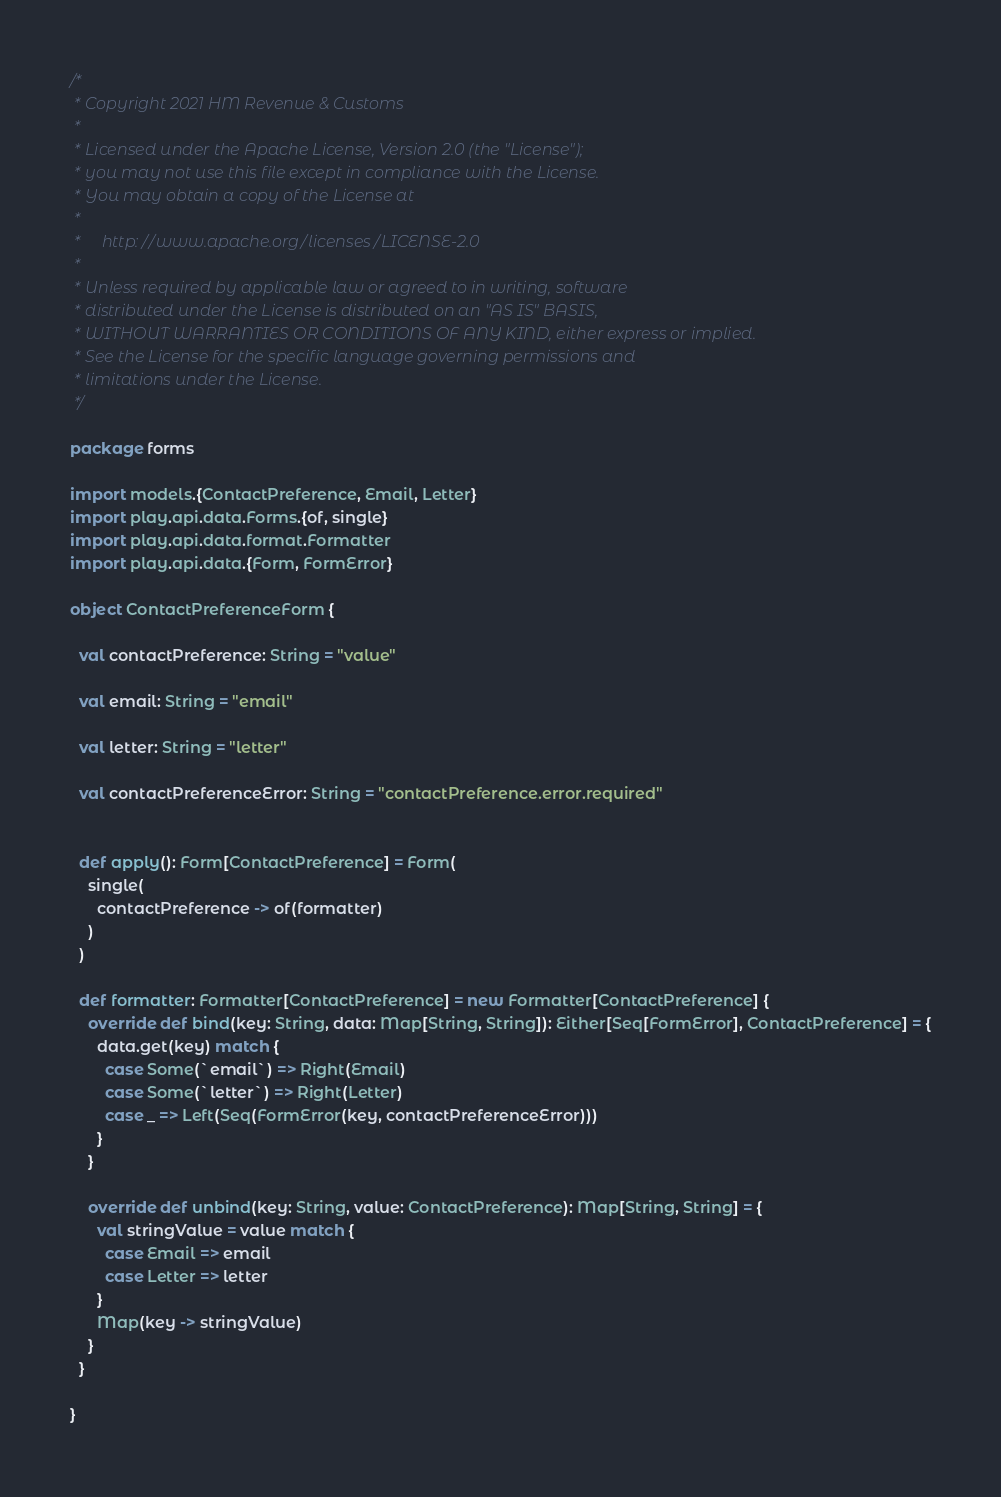Convert code to text. <code><loc_0><loc_0><loc_500><loc_500><_Scala_>/*
 * Copyright 2021 HM Revenue & Customs
 *
 * Licensed under the Apache License, Version 2.0 (the "License");
 * you may not use this file except in compliance with the License.
 * You may obtain a copy of the License at
 *
 *     http://www.apache.org/licenses/LICENSE-2.0
 *
 * Unless required by applicable law or agreed to in writing, software
 * distributed under the License is distributed on an "AS IS" BASIS,
 * WITHOUT WARRANTIES OR CONDITIONS OF ANY KIND, either express or implied.
 * See the License for the specific language governing permissions and
 * limitations under the License.
 */

package forms

import models.{ContactPreference, Email, Letter}
import play.api.data.Forms.{of, single}
import play.api.data.format.Formatter
import play.api.data.{Form, FormError}

object ContactPreferenceForm {

  val contactPreference: String = "value"

  val email: String = "email"

  val letter: String = "letter"

  val contactPreferenceError: String = "contactPreference.error.required"


  def apply(): Form[ContactPreference] = Form(
    single(
      contactPreference -> of(formatter)
    )
  )

  def formatter: Formatter[ContactPreference] = new Formatter[ContactPreference] {
    override def bind(key: String, data: Map[String, String]): Either[Seq[FormError], ContactPreference] = {
      data.get(key) match {
        case Some(`email`) => Right(Email)
        case Some(`letter`) => Right(Letter)
        case _ => Left(Seq(FormError(key, contactPreferenceError)))
      }
    }

    override def unbind(key: String, value: ContactPreference): Map[String, String] = {
      val stringValue = value match {
        case Email => email
        case Letter => letter
      }
      Map(key -> stringValue)
    }
  }

}
</code> 